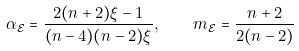<formula> <loc_0><loc_0><loc_500><loc_500>\alpha _ { \mathcal { E } } = \frac { 2 ( n + 2 ) \xi - 1 } { ( n - 4 ) ( n - 2 ) \xi } , \quad m _ { \mathcal { E } } = \frac { n + 2 } { 2 ( n - 2 ) }</formula> 